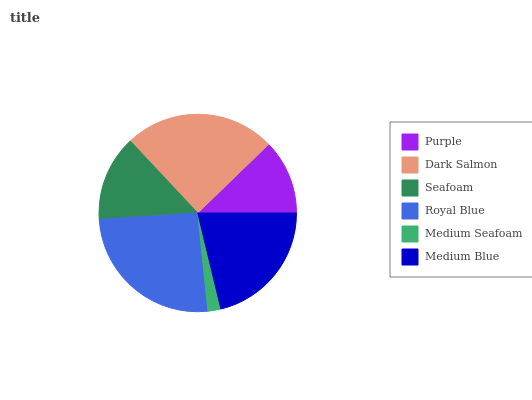Is Medium Seafoam the minimum?
Answer yes or no. Yes. Is Royal Blue the maximum?
Answer yes or no. Yes. Is Dark Salmon the minimum?
Answer yes or no. No. Is Dark Salmon the maximum?
Answer yes or no. No. Is Dark Salmon greater than Purple?
Answer yes or no. Yes. Is Purple less than Dark Salmon?
Answer yes or no. Yes. Is Purple greater than Dark Salmon?
Answer yes or no. No. Is Dark Salmon less than Purple?
Answer yes or no. No. Is Medium Blue the high median?
Answer yes or no. Yes. Is Seafoam the low median?
Answer yes or no. Yes. Is Royal Blue the high median?
Answer yes or no. No. Is Royal Blue the low median?
Answer yes or no. No. 